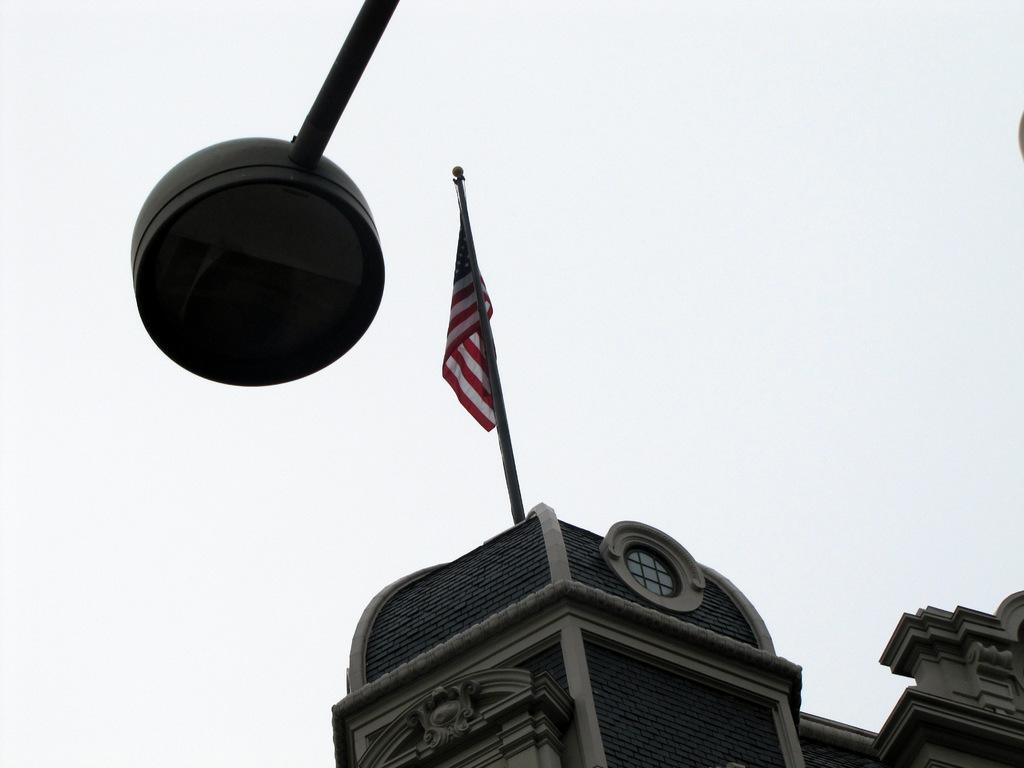In one or two sentences, can you explain what this image depicts? On the left side of the image we can see a pole light, in the background we can find few buildings and a flag. 